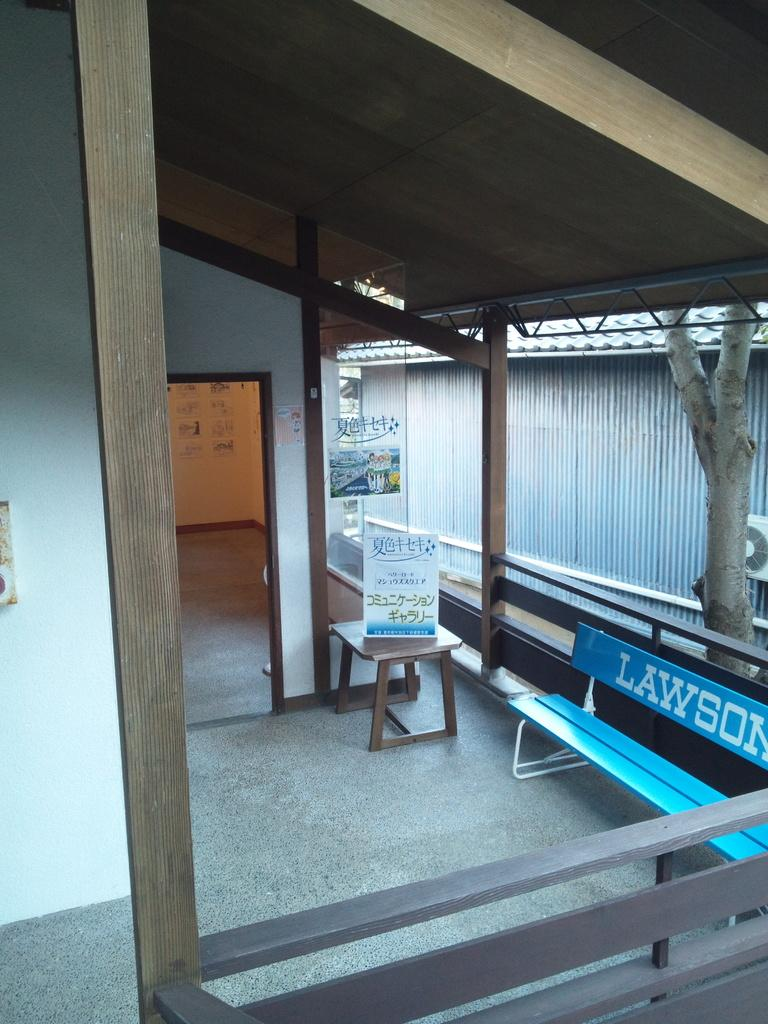<image>
Create a compact narrative representing the image presented. An enclosed sitting area has a blue bench with Lawson written on it. 